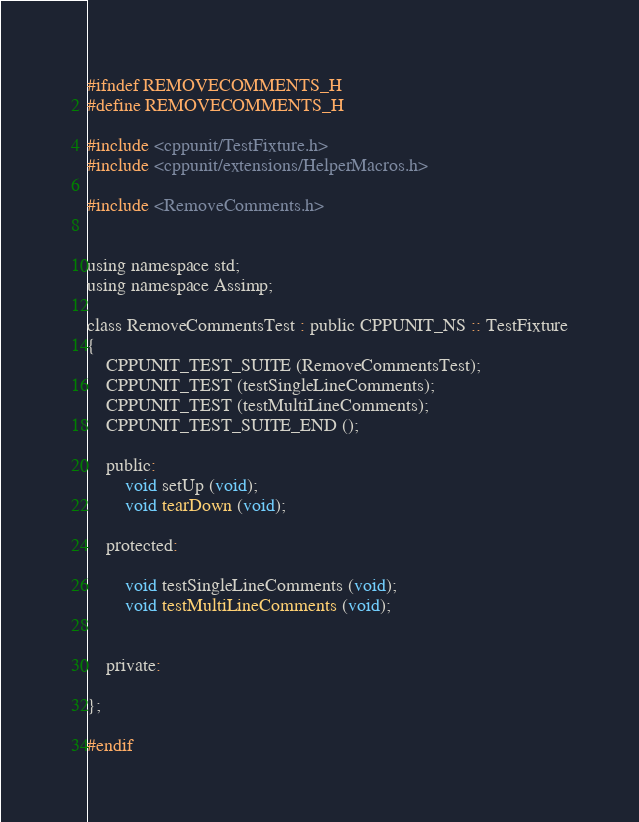<code> <loc_0><loc_0><loc_500><loc_500><_C_>#ifndef REMOVECOMMENTS_H
#define REMOVECOMMENTS_H

#include <cppunit/TestFixture.h>
#include <cppunit/extensions/HelperMacros.h>

#include <RemoveComments.h>


using namespace std;
using namespace Assimp;

class RemoveCommentsTest : public CPPUNIT_NS :: TestFixture
{
    CPPUNIT_TEST_SUITE (RemoveCommentsTest);
    CPPUNIT_TEST (testSingleLineComments);
	CPPUNIT_TEST (testMultiLineComments);
    CPPUNIT_TEST_SUITE_END ();

    public:
        void setUp (void);
        void tearDown (void);

    protected:

        void testSingleLineComments (void);
		void testMultiLineComments (void);
		
   
	private:

};

#endif 
</code> 